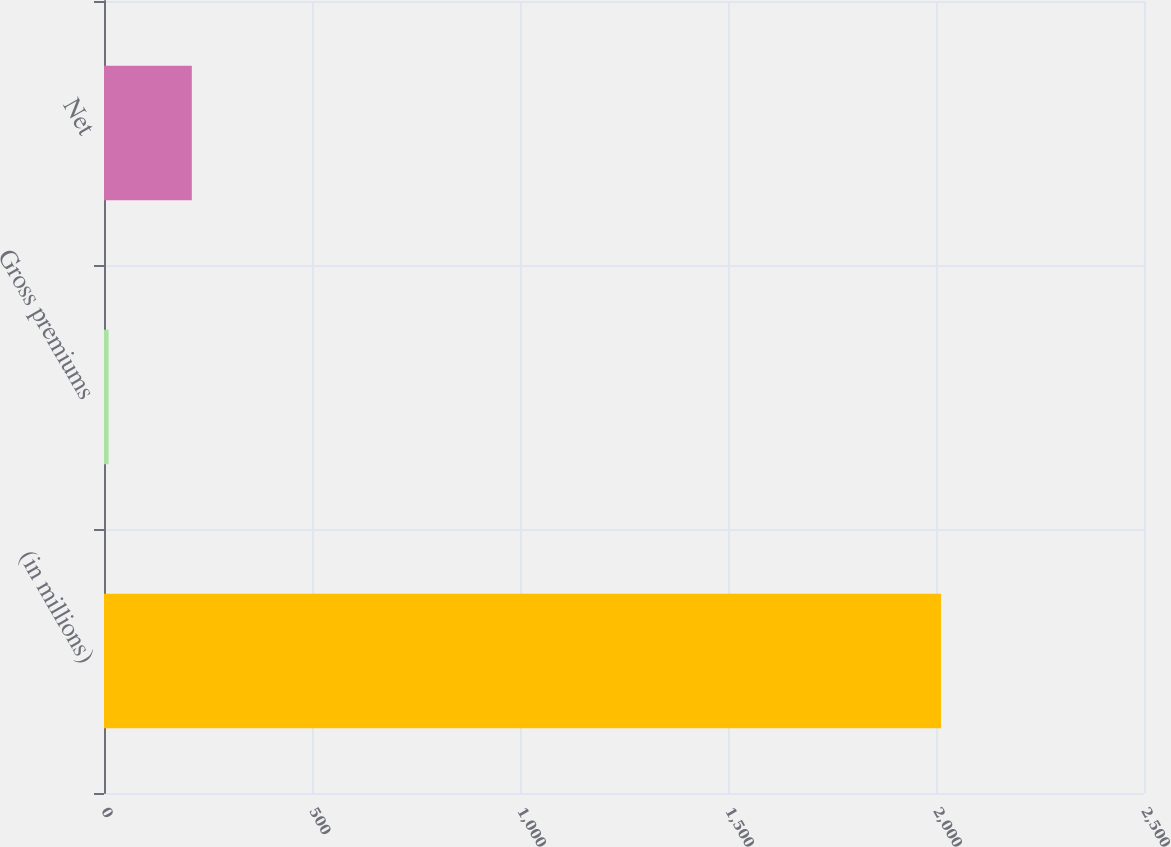Convert chart to OTSL. <chart><loc_0><loc_0><loc_500><loc_500><bar_chart><fcel>(in millions)<fcel>Gross premiums<fcel>Net<nl><fcel>2012<fcel>11<fcel>211.1<nl></chart> 